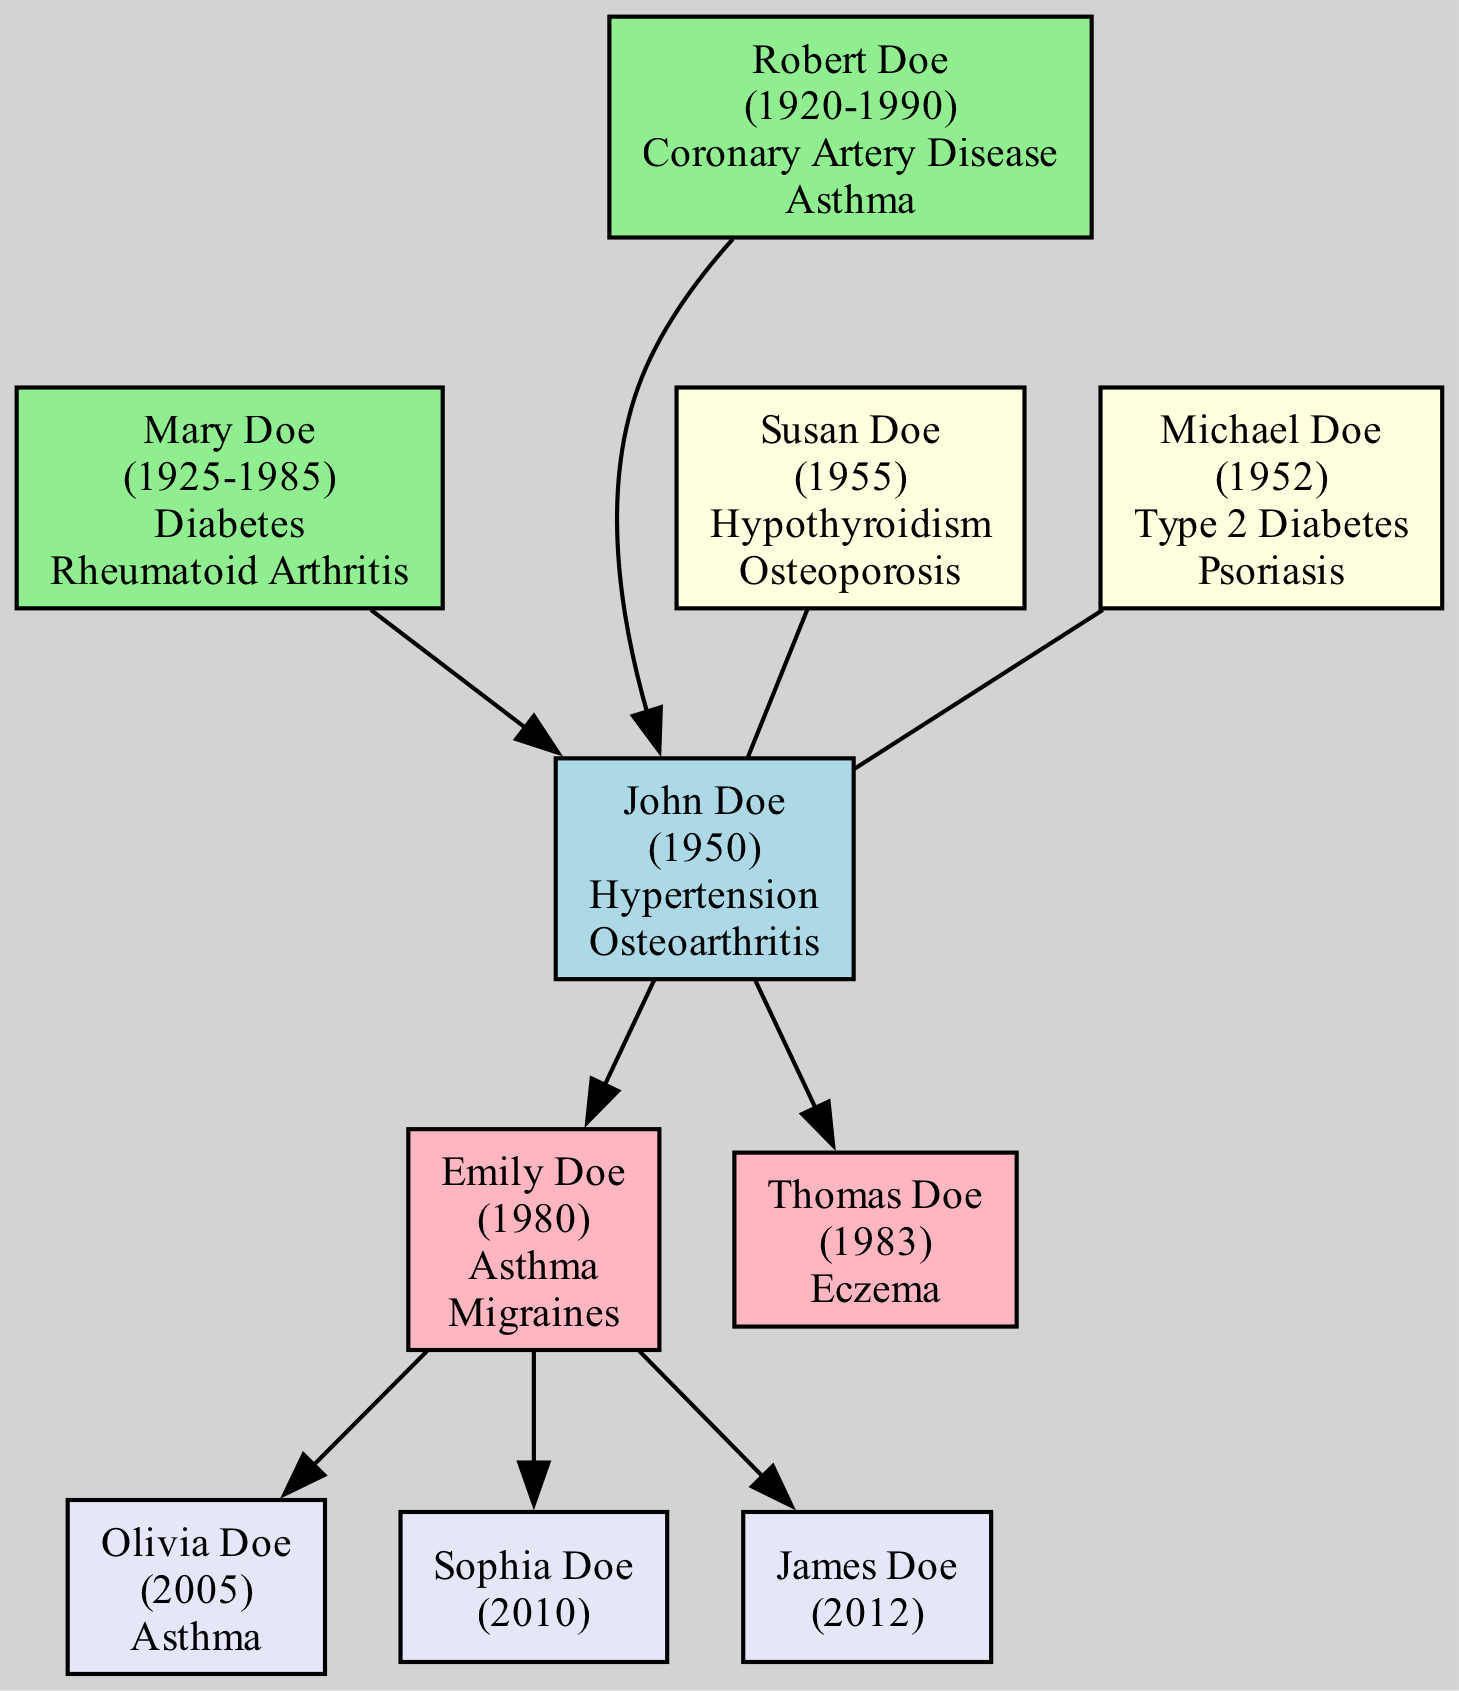What are the chronic conditions of John Doe? The chronic conditions of John Doe are mentioned directly under his name in the diagram. They are listed as "Hypertension" and "Osteoarthritis."
Answer: Hypertension, Osteoarthritis How many siblings does John Doe have? By counting the boxes connected to John Doe that represent siblings, we find Susan Doe and Michael Doe, making a total of two siblings.
Answer: 2 What chronic condition is shared between John Doe and his sister Susan? Both John Doe and his sister Susan have "Osteoarthritis," as can be seen in their respective boxes under the chronic conditions section of the diagram.
Answer: Osteoarthritis Who are the grandchildren of John Doe? The grandchildren of John Doe are listed in the diagram, and include Olivia Doe, Sophia Doe, and James Doe.
Answer: Olivia Doe, Sophia Doe, James Doe Which parent of John Doe had chronic conditions related to heart disease? John Doe's father, Robert Doe, has chronic conditions that include "Coronary Artery Disease," which indicates a chronic condition related to heart disease.
Answer: Robert Doe What is the birth year of John's mother? The birth year of John Doe's mother, Mary Doe, is indicated in the diagram as 1925.
Answer: 1925 How many chronic conditions does Emily Doe have? Emily Doe's chronic conditions are shown in her box, which lists "Asthma" and "Migraines," totaling two chronic conditions.
Answer: 2 Is there any chronic condition listed for Sophia Doe? According to the diagram, Sophia Doe has no chronic conditions listed, as her box is empty in the chronic conditions section.
Answer: None Which sibling of John Doe has Type 2 Diabetes? The diagram indicates that Michael Doe, John's sibling, has "Type 2 Diabetes" among his chronic conditions, making him the sibling with this condition.
Answer: Michael Doe 